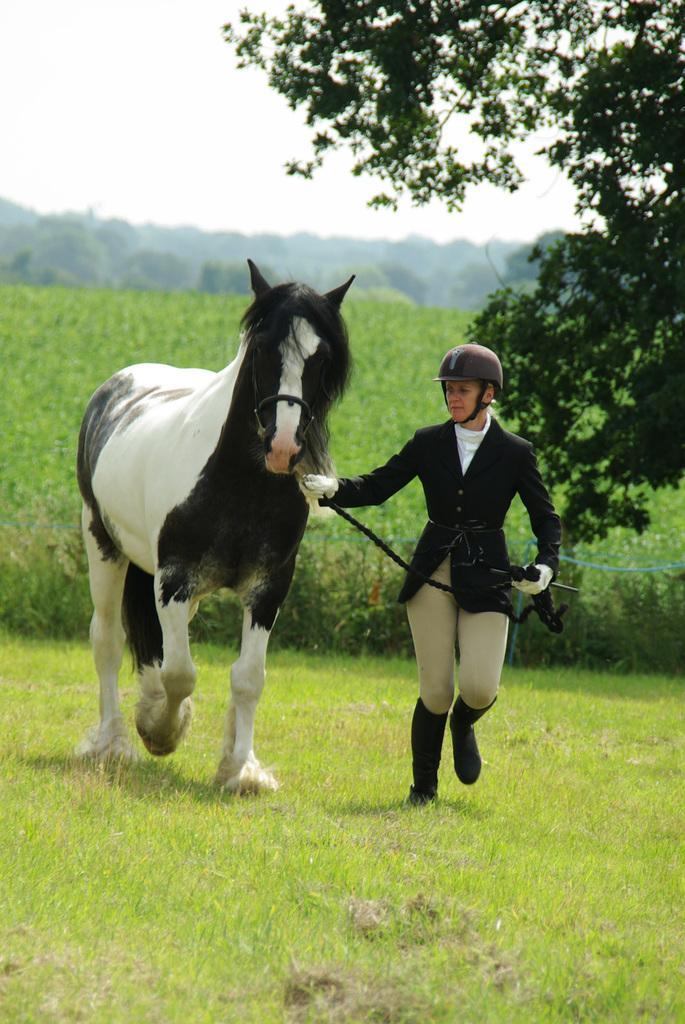Please provide a concise description of this image. This image consists of a horse in black and white color. Beside that, there is a person running is wearing a black coat. At the bottom, there is green grass. In the background, there are plants. On the right, there is a tree. At the top, there is sky. 